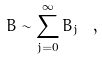<formula> <loc_0><loc_0><loc_500><loc_500>B \sim \sum _ { j = 0 } ^ { \infty } B _ { j } \ ,</formula> 